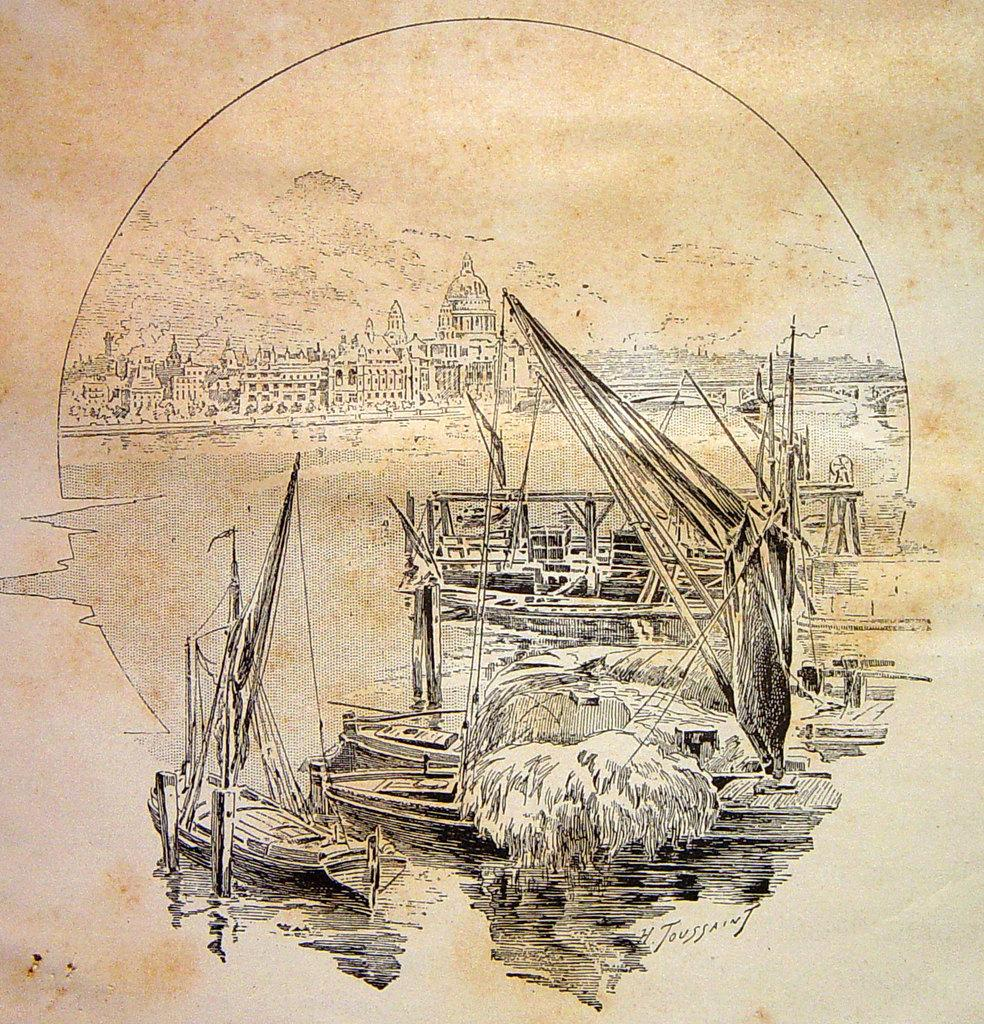What is featured on the poster in the image? There is a poster in the image that includes buildings and boats. Can you describe the content of the poster in more detail? The poster features buildings and boats, which suggests it might be a scene from a city with a waterfront or harbor. What type of exchange can be seen taking place in the background of the poster? There is no exchange depicted in the background of the poster; it only features buildings and boats. 